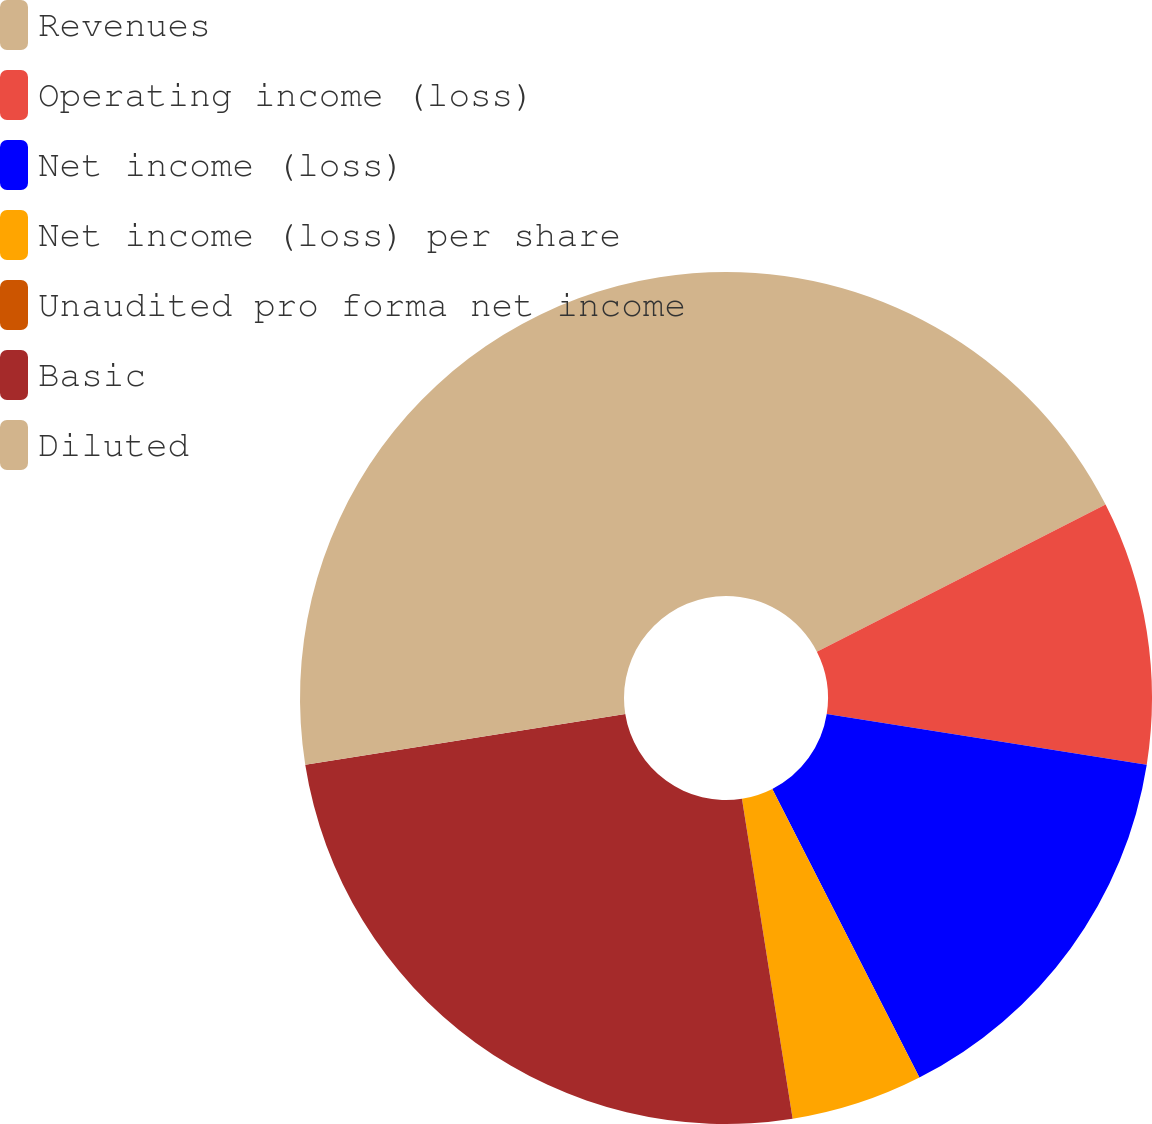Convert chart. <chart><loc_0><loc_0><loc_500><loc_500><pie_chart><fcel>Revenues<fcel>Operating income (loss)<fcel>Net income (loss)<fcel>Net income (loss) per share<fcel>Unaudited pro forma net income<fcel>Basic<fcel>Diluted<nl><fcel>17.5%<fcel>10.0%<fcel>15.0%<fcel>5.0%<fcel>0.0%<fcel>25.0%<fcel>27.5%<nl></chart> 